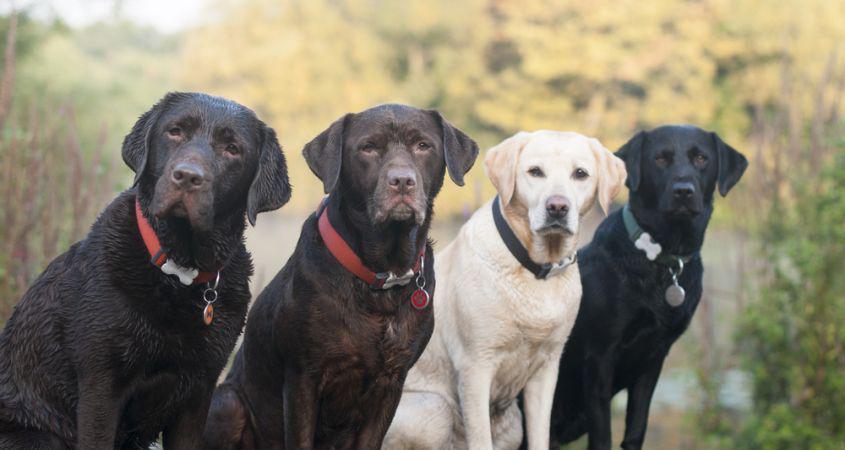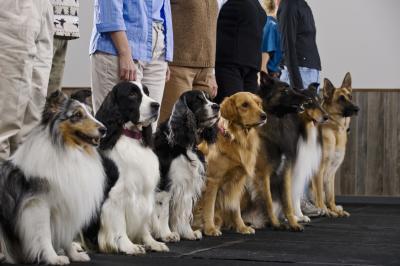The first image is the image on the left, the second image is the image on the right. For the images shown, is this caption "There are six dogs in total." true? Answer yes or no. No. The first image is the image on the left, the second image is the image on the right. Considering the images on both sides, is "A person's legs are visible behind at least one dog." valid? Answer yes or no. Yes. 